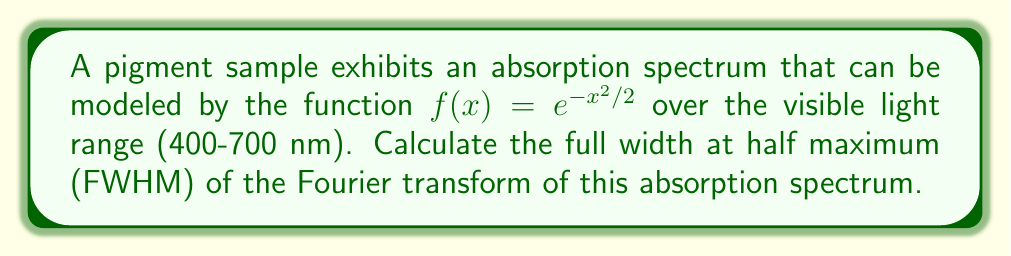Solve this math problem. To solve this problem, we'll follow these steps:

1) The given function $f(x) = e^{-x^2/2}$ is a Gaussian function.

2) The Fourier transform of a Gaussian function is also a Gaussian function. For $f(x) = e^{-ax^2}$, its Fourier transform is:

   $$F(k) = \sqrt{\frac{\pi}{a}} e^{-k^2/(4a)}$$

3) In our case, $a = 1/2$, so the Fourier transform is:

   $$F(k) = \sqrt{2\pi} e^{-k^2/2}$$

4) The FWHM is the width of the function at half its maximum value. For a Gaussian function $g(x) = Ae^{-bx^2}$, the FWHM is given by:

   $$\text{FWHM} = 2\sqrt{\frac{\ln 2}{b}}$$

5) In our Fourier transform, $A = \sqrt{2\pi}$ and $b = 1/2$. So:

   $$\text{FWHM} = 2\sqrt{\frac{\ln 2}{1/2}} = 2\sqrt{2\ln 2}$$

6) Simplify:

   $$\text{FWHM} = 2\sqrt{2\ln 2} \approx 2.355$$
Answer: $2\sqrt{2\ln 2}$ 